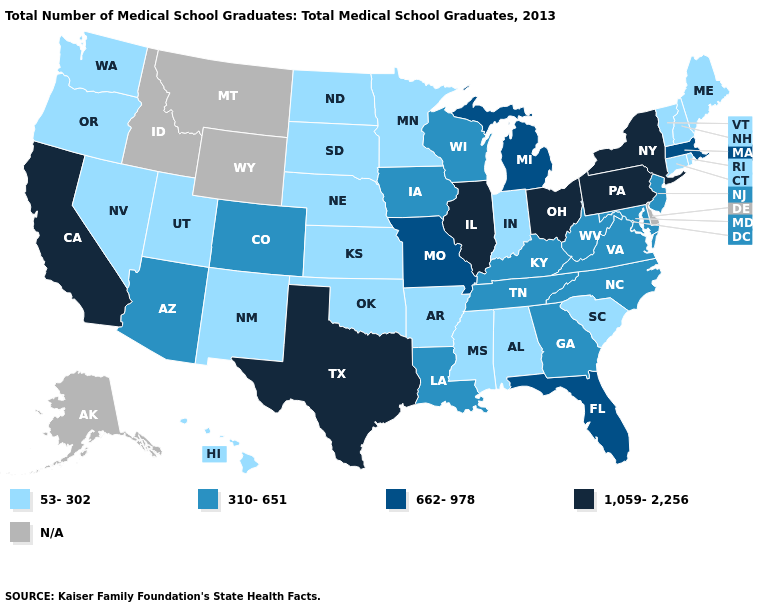What is the value of North Carolina?
Short answer required. 310-651. What is the value of Utah?
Answer briefly. 53-302. What is the value of Idaho?
Concise answer only. N/A. Name the states that have a value in the range 53-302?
Write a very short answer. Alabama, Arkansas, Connecticut, Hawaii, Indiana, Kansas, Maine, Minnesota, Mississippi, Nebraska, Nevada, New Hampshire, New Mexico, North Dakota, Oklahoma, Oregon, Rhode Island, South Carolina, South Dakota, Utah, Vermont, Washington. Among the states that border West Virginia , does Kentucky have the highest value?
Keep it brief. No. How many symbols are there in the legend?
Give a very brief answer. 5. Among the states that border Maine , which have the highest value?
Be succinct. New Hampshire. What is the value of Minnesota?
Short answer required. 53-302. What is the lowest value in states that border Utah?
Keep it brief. 53-302. What is the lowest value in states that border Wyoming?
Short answer required. 53-302. Which states hav the highest value in the West?
Be succinct. California. What is the lowest value in the USA?
Be succinct. 53-302. Does the first symbol in the legend represent the smallest category?
Be succinct. Yes. Does the map have missing data?
Be succinct. Yes. 